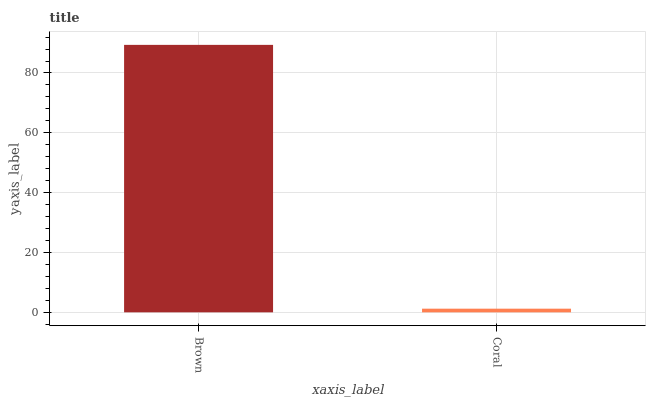Is Coral the maximum?
Answer yes or no. No. Is Brown greater than Coral?
Answer yes or no. Yes. Is Coral less than Brown?
Answer yes or no. Yes. Is Coral greater than Brown?
Answer yes or no. No. Is Brown less than Coral?
Answer yes or no. No. Is Brown the high median?
Answer yes or no. Yes. Is Coral the low median?
Answer yes or no. Yes. Is Coral the high median?
Answer yes or no. No. Is Brown the low median?
Answer yes or no. No. 